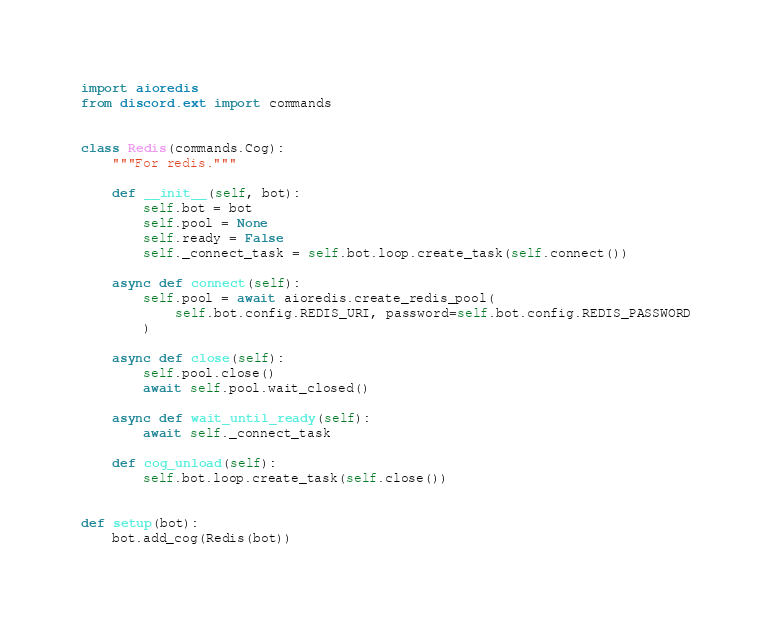Convert code to text. <code><loc_0><loc_0><loc_500><loc_500><_Python_>import aioredis
from discord.ext import commands


class Redis(commands.Cog):
    """For redis."""

    def __init__(self, bot):
        self.bot = bot
        self.pool = None
        self.ready = False
        self._connect_task = self.bot.loop.create_task(self.connect())

    async def connect(self):
        self.pool = await aioredis.create_redis_pool(
            self.bot.config.REDIS_URI, password=self.bot.config.REDIS_PASSWORD
        )

    async def close(self):
        self.pool.close()
        await self.pool.wait_closed()

    async def wait_until_ready(self):
        await self._connect_task

    def cog_unload(self):
        self.bot.loop.create_task(self.close())


def setup(bot):
    bot.add_cog(Redis(bot))
</code> 